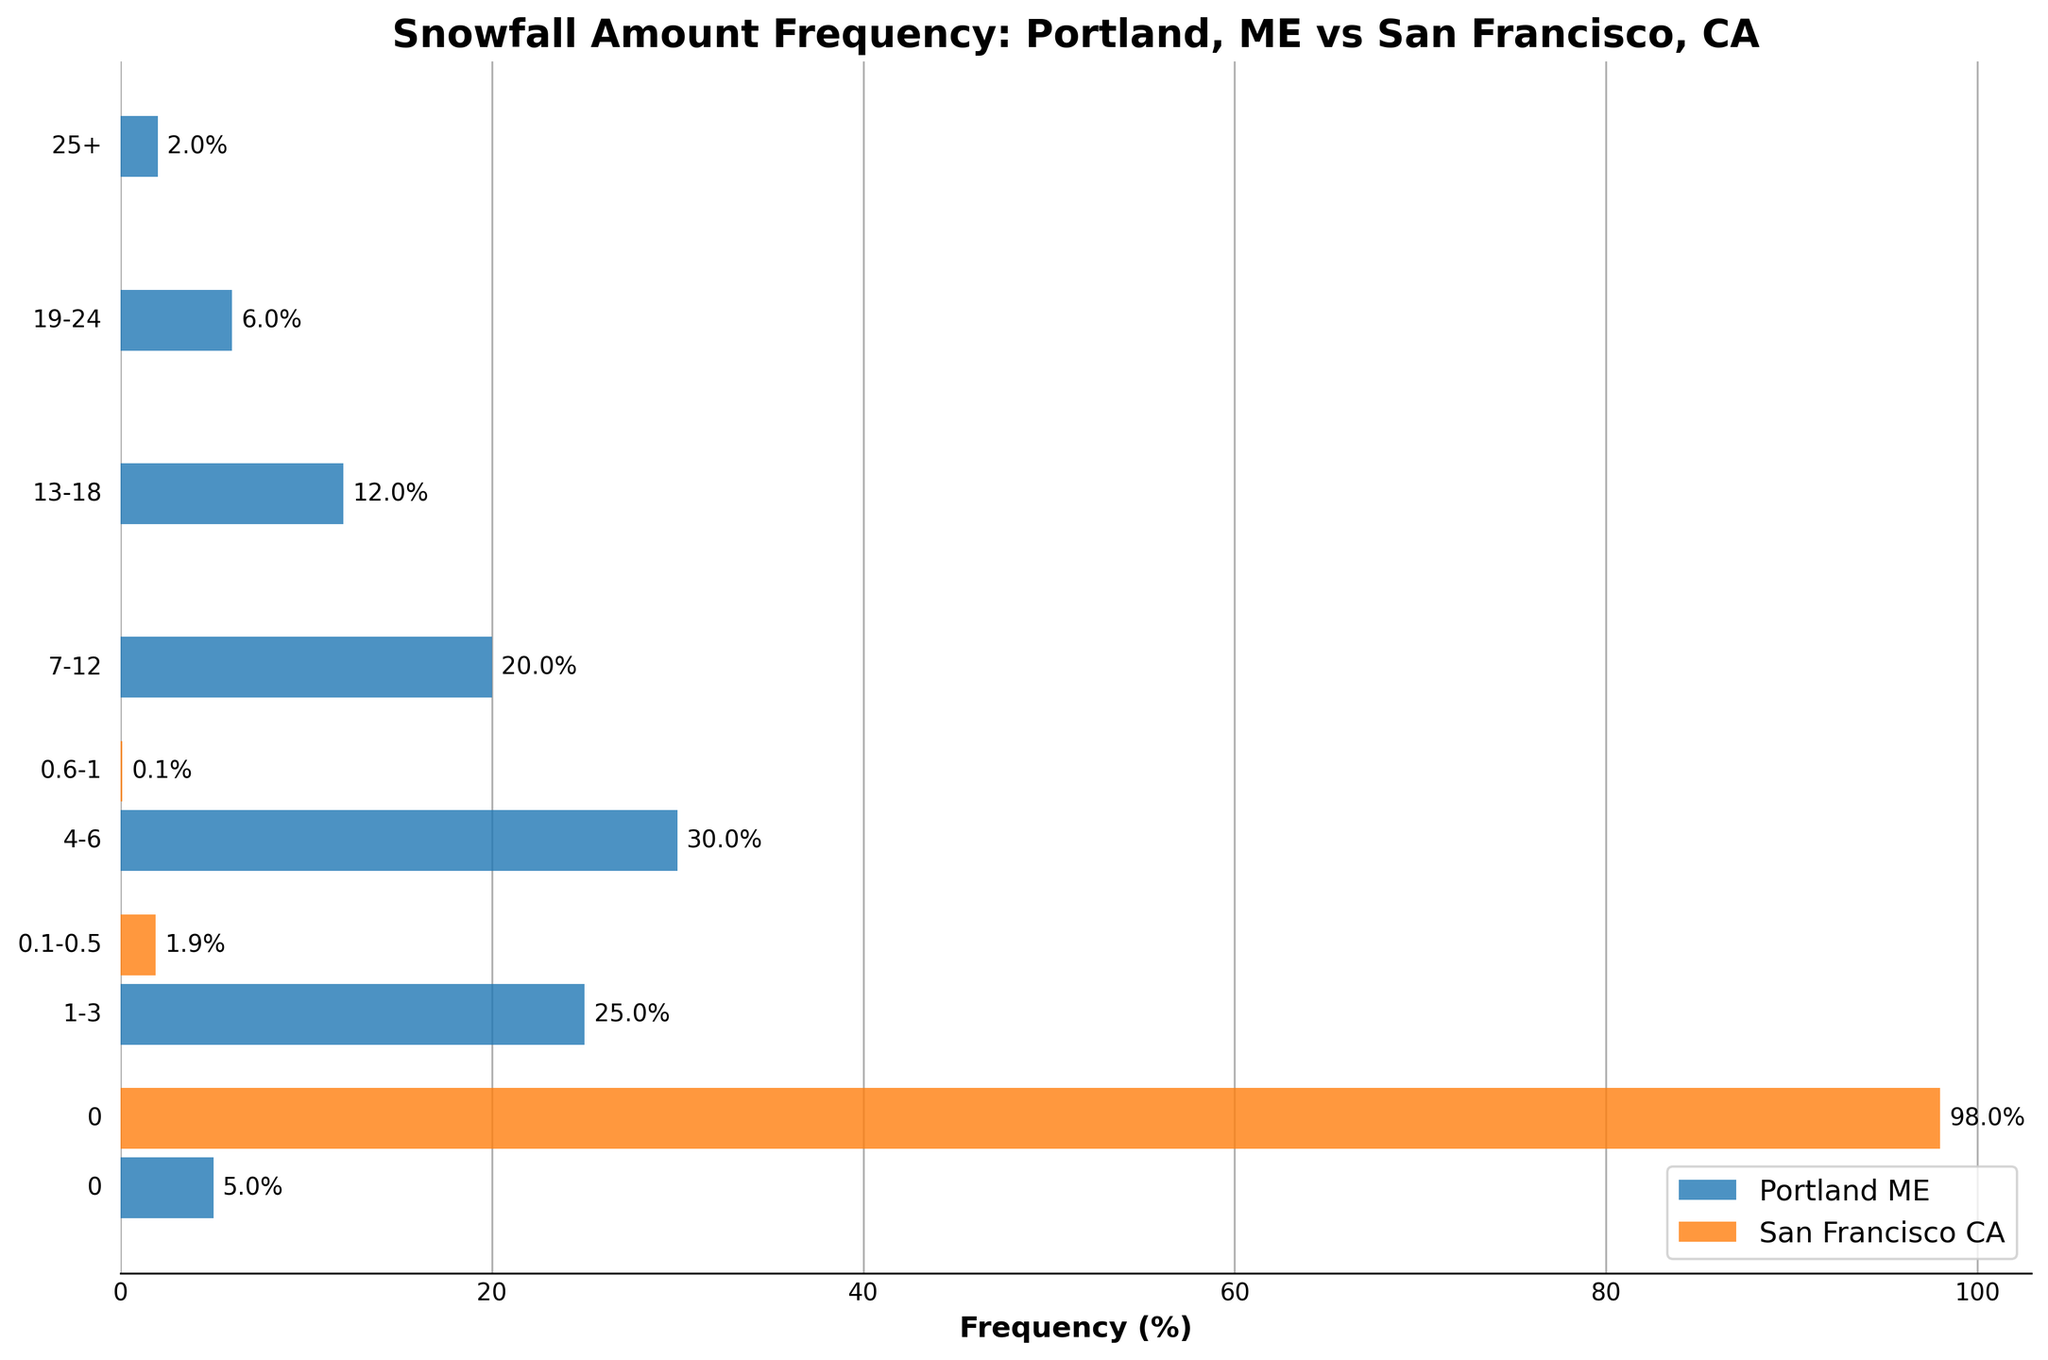What is the title of the plot? The title is displayed at the top of the plot, stating the main focus of the figure.
Answer: Snowfall Amount Frequency: Portland, ME vs San Francisco, CA Which city has a higher frequency of days with 0 inches of snowfall? Look at the horizontal bars representing 0 inches of snowfall for each city. Portland, ME has a smaller bar compared to San Francisco, CA.
Answer: San Francisco, CA What is the frequency percentage for Portland, ME for snowfall amounts of 4-6 inches? Look at the bar representing Portland, ME for the snowfall amount of 4-6 inches. The figure next to the bar shows this value.
Answer: 30% How does the frequency of snowfall amounts of 13-18 inches in Portland, ME compare to its 19-24 inches snowfall amounts? Compare the respective lengths of the bars for 13-18 inches and 19-24 inches for Portland, ME.
Answer: The 13-18 inches frequency (12%) is higher than the 19-24 inches frequency (6%) Which snowfall amount has the highest frequency in Portland, ME? Identify the longest horizontal bar under Portland, ME.
Answer: 4-6 inches What is the combined frequency of all measurable snowfall amounts (greater than 0 inches) in San Francisco, CA? Summing up the frequencies for the snowfall ranges 0.1-0.5 and 0.6-1 inches for San Francisco, CA: 1.9% + 0.1% = 2%.
Answer: 2% What is the difference in frequency percentage for 0 inches of snowfall between Portland, ME and San Francisco, CA? Subtract the frequency percentage of 0 inches of snowfall for Portland, ME from that of San Francisco, CA: 98% - 5% = 93%.
Answer: 93% Which city has more diversified snowfall amounts? Compare the number and range of different snowfall amounts listed for both cities. Portland, ME shows a wider diversification of snowfall amounts compared to San Francisco, CA.
Answer: Portland, ME What's the combined frequency of snowfall amounts greater than or equal to 13 inches in Portland, ME? Adding up the frequencies for 13-18, 19-24, and 25+ inches in Portland, ME: 12% + 6% + 2% = 20%.
Answer: 20% 